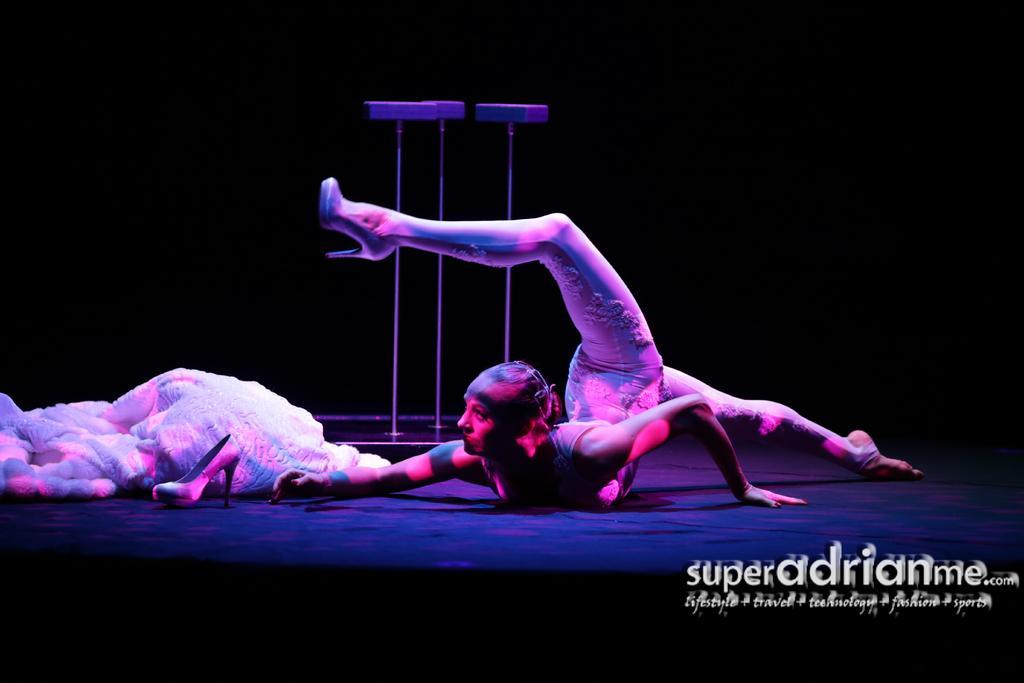How would you summarize this image in a sentence or two? In this picture there is a woman and we can see clothing, footwear and objects. In the background of the image it is dark. In the bottom right side of the image we can see text. 